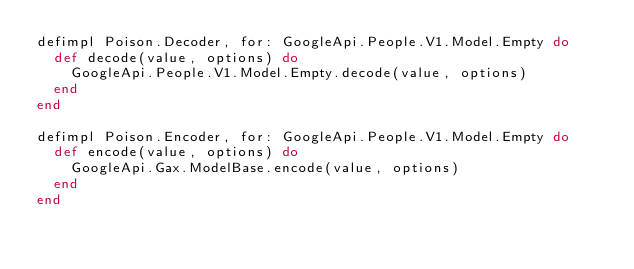Convert code to text. <code><loc_0><loc_0><loc_500><loc_500><_Elixir_>defimpl Poison.Decoder, for: GoogleApi.People.V1.Model.Empty do
  def decode(value, options) do
    GoogleApi.People.V1.Model.Empty.decode(value, options)
  end
end

defimpl Poison.Encoder, for: GoogleApi.People.V1.Model.Empty do
  def encode(value, options) do
    GoogleApi.Gax.ModelBase.encode(value, options)
  end
end
</code> 